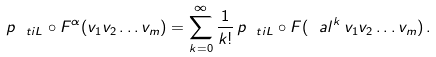Convert formula to latex. <formula><loc_0><loc_0><loc_500><loc_500>p _ { \ t i { L } } \circ F ^ { \alpha } ( v _ { 1 } v _ { 2 } \dots v _ { m } ) = \sum _ { k = 0 } ^ { \infty } \frac { 1 } { k ! } \, p _ { \ t i { L } } \circ F ( \ a l ^ { k } \, v _ { 1 } v _ { 2 } \dots v _ { m } ) \, .</formula> 